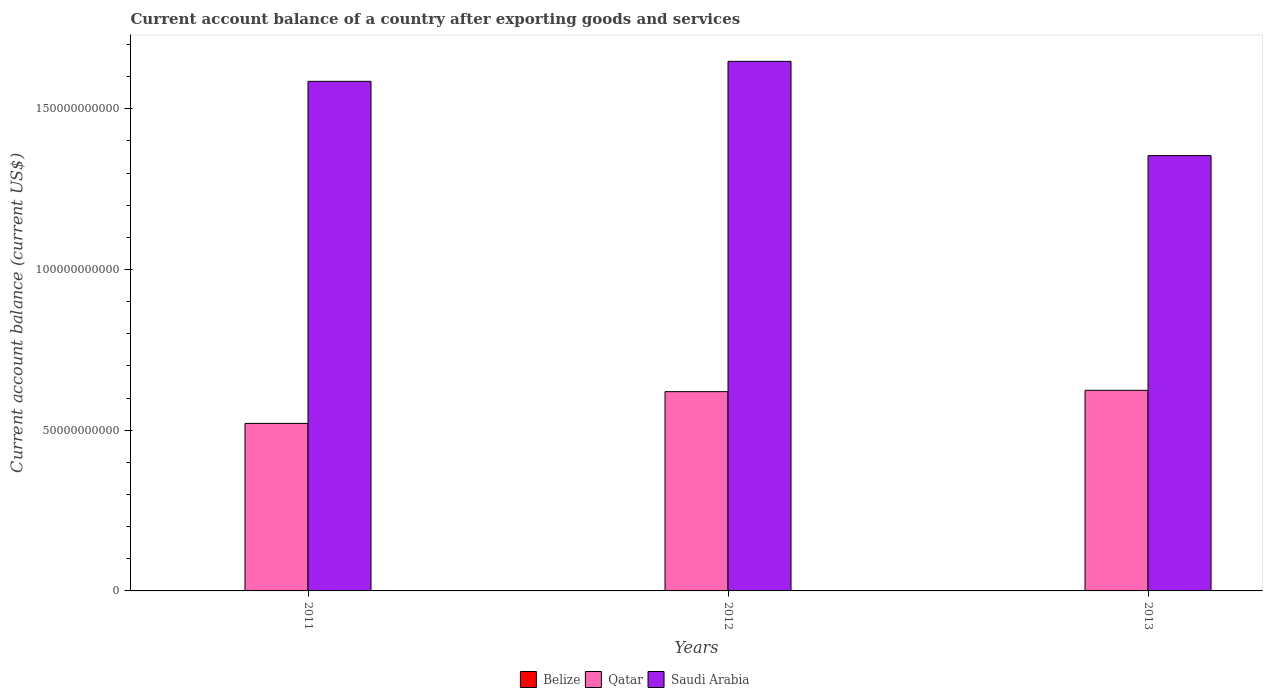In how many cases, is the number of bars for a given year not equal to the number of legend labels?
Offer a terse response. 3. What is the account balance in Saudi Arabia in 2013?
Keep it short and to the point. 1.35e+11. Across all years, what is the maximum account balance in Saudi Arabia?
Ensure brevity in your answer.  1.65e+11. In which year was the account balance in Qatar maximum?
Provide a succinct answer. 2013. What is the total account balance in Qatar in the graph?
Offer a very short reply. 1.77e+11. What is the difference between the account balance in Saudi Arabia in 2011 and that in 2013?
Offer a terse response. 2.31e+1. What is the difference between the account balance in Qatar in 2011 and the account balance in Saudi Arabia in 2013?
Make the answer very short. -8.33e+1. What is the average account balance in Saudi Arabia per year?
Give a very brief answer. 1.53e+11. In the year 2011, what is the difference between the account balance in Qatar and account balance in Saudi Arabia?
Make the answer very short. -1.06e+11. In how many years, is the account balance in Qatar greater than 30000000000 US$?
Provide a succinct answer. 3. What is the ratio of the account balance in Qatar in 2011 to that in 2013?
Your response must be concise. 0.84. What is the difference between the highest and the second highest account balance in Qatar?
Provide a short and direct response. 4.18e+08. What is the difference between the highest and the lowest account balance in Qatar?
Your answer should be compact. 1.03e+1. Is the sum of the account balance in Qatar in 2011 and 2012 greater than the maximum account balance in Belize across all years?
Provide a short and direct response. Yes. Is it the case that in every year, the sum of the account balance in Belize and account balance in Saudi Arabia is greater than the account balance in Qatar?
Your answer should be very brief. Yes. How many bars are there?
Offer a very short reply. 6. How are the legend labels stacked?
Ensure brevity in your answer.  Horizontal. What is the title of the graph?
Ensure brevity in your answer.  Current account balance of a country after exporting goods and services. What is the label or title of the Y-axis?
Make the answer very short. Current account balance (current US$). What is the Current account balance (current US$) of Qatar in 2011?
Your response must be concise. 5.21e+1. What is the Current account balance (current US$) of Saudi Arabia in 2011?
Give a very brief answer. 1.59e+11. What is the Current account balance (current US$) in Belize in 2012?
Your answer should be compact. 0. What is the Current account balance (current US$) in Qatar in 2012?
Provide a succinct answer. 6.20e+1. What is the Current account balance (current US$) in Saudi Arabia in 2012?
Your answer should be very brief. 1.65e+11. What is the Current account balance (current US$) in Belize in 2013?
Offer a terse response. 0. What is the Current account balance (current US$) in Qatar in 2013?
Your response must be concise. 6.24e+1. What is the Current account balance (current US$) in Saudi Arabia in 2013?
Provide a succinct answer. 1.35e+11. Across all years, what is the maximum Current account balance (current US$) in Qatar?
Offer a terse response. 6.24e+1. Across all years, what is the maximum Current account balance (current US$) in Saudi Arabia?
Your answer should be compact. 1.65e+11. Across all years, what is the minimum Current account balance (current US$) of Qatar?
Offer a very short reply. 5.21e+1. Across all years, what is the minimum Current account balance (current US$) of Saudi Arabia?
Provide a succinct answer. 1.35e+11. What is the total Current account balance (current US$) in Belize in the graph?
Provide a short and direct response. 0. What is the total Current account balance (current US$) of Qatar in the graph?
Provide a succinct answer. 1.77e+11. What is the total Current account balance (current US$) of Saudi Arabia in the graph?
Provide a short and direct response. 4.59e+11. What is the difference between the Current account balance (current US$) of Qatar in 2011 and that in 2012?
Your response must be concise. -9.88e+09. What is the difference between the Current account balance (current US$) in Saudi Arabia in 2011 and that in 2012?
Ensure brevity in your answer.  -6.22e+09. What is the difference between the Current account balance (current US$) of Qatar in 2011 and that in 2013?
Your answer should be very brief. -1.03e+1. What is the difference between the Current account balance (current US$) in Saudi Arabia in 2011 and that in 2013?
Keep it short and to the point. 2.31e+1. What is the difference between the Current account balance (current US$) of Qatar in 2012 and that in 2013?
Make the answer very short. -4.18e+08. What is the difference between the Current account balance (current US$) in Saudi Arabia in 2012 and that in 2013?
Your response must be concise. 2.93e+1. What is the difference between the Current account balance (current US$) in Qatar in 2011 and the Current account balance (current US$) in Saudi Arabia in 2012?
Ensure brevity in your answer.  -1.13e+11. What is the difference between the Current account balance (current US$) in Qatar in 2011 and the Current account balance (current US$) in Saudi Arabia in 2013?
Offer a terse response. -8.33e+1. What is the difference between the Current account balance (current US$) of Qatar in 2012 and the Current account balance (current US$) of Saudi Arabia in 2013?
Your answer should be very brief. -7.34e+1. What is the average Current account balance (current US$) of Belize per year?
Offer a very short reply. 0. What is the average Current account balance (current US$) in Qatar per year?
Give a very brief answer. 5.88e+1. What is the average Current account balance (current US$) of Saudi Arabia per year?
Offer a very short reply. 1.53e+11. In the year 2011, what is the difference between the Current account balance (current US$) of Qatar and Current account balance (current US$) of Saudi Arabia?
Your answer should be very brief. -1.06e+11. In the year 2012, what is the difference between the Current account balance (current US$) of Qatar and Current account balance (current US$) of Saudi Arabia?
Your answer should be very brief. -1.03e+11. In the year 2013, what is the difference between the Current account balance (current US$) of Qatar and Current account balance (current US$) of Saudi Arabia?
Give a very brief answer. -7.30e+1. What is the ratio of the Current account balance (current US$) of Qatar in 2011 to that in 2012?
Give a very brief answer. 0.84. What is the ratio of the Current account balance (current US$) in Saudi Arabia in 2011 to that in 2012?
Your answer should be very brief. 0.96. What is the ratio of the Current account balance (current US$) of Qatar in 2011 to that in 2013?
Ensure brevity in your answer.  0.84. What is the ratio of the Current account balance (current US$) in Saudi Arabia in 2011 to that in 2013?
Provide a succinct answer. 1.17. What is the ratio of the Current account balance (current US$) of Qatar in 2012 to that in 2013?
Your answer should be compact. 0.99. What is the ratio of the Current account balance (current US$) of Saudi Arabia in 2012 to that in 2013?
Your response must be concise. 1.22. What is the difference between the highest and the second highest Current account balance (current US$) in Qatar?
Offer a terse response. 4.18e+08. What is the difference between the highest and the second highest Current account balance (current US$) of Saudi Arabia?
Ensure brevity in your answer.  6.22e+09. What is the difference between the highest and the lowest Current account balance (current US$) of Qatar?
Provide a short and direct response. 1.03e+1. What is the difference between the highest and the lowest Current account balance (current US$) of Saudi Arabia?
Your response must be concise. 2.93e+1. 